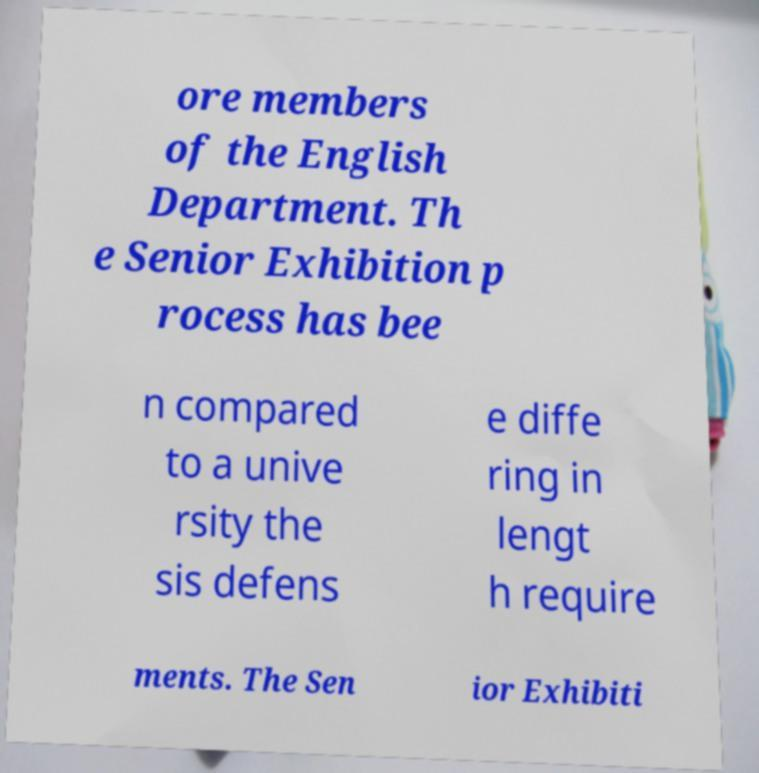Please identify and transcribe the text found in this image. ore members of the English Department. Th e Senior Exhibition p rocess has bee n compared to a unive rsity the sis defens e diffe ring in lengt h require ments. The Sen ior Exhibiti 